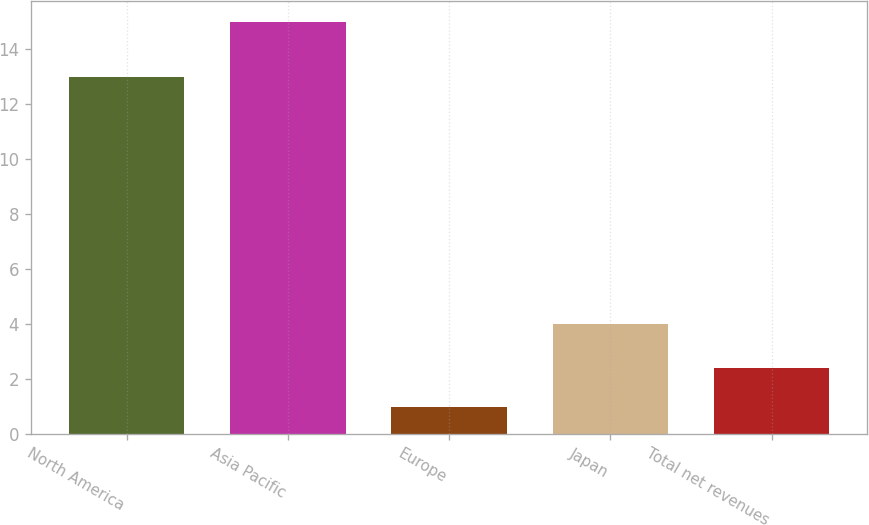Convert chart. <chart><loc_0><loc_0><loc_500><loc_500><bar_chart><fcel>North America<fcel>Asia Pacific<fcel>Europe<fcel>Japan<fcel>Total net revenues<nl><fcel>13<fcel>15<fcel>1<fcel>4<fcel>2.4<nl></chart> 